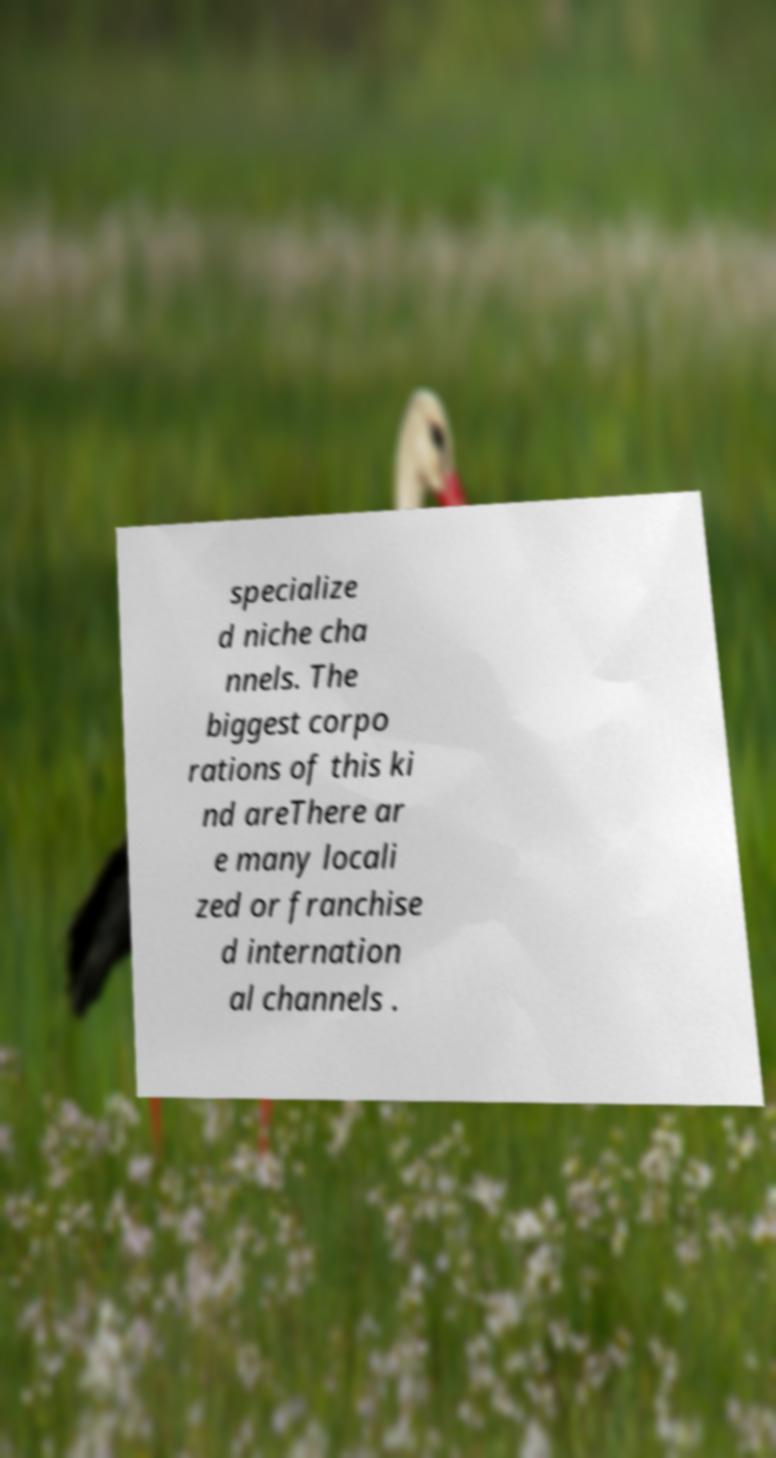Could you assist in decoding the text presented in this image and type it out clearly? specialize d niche cha nnels. The biggest corpo rations of this ki nd areThere ar e many locali zed or franchise d internation al channels . 